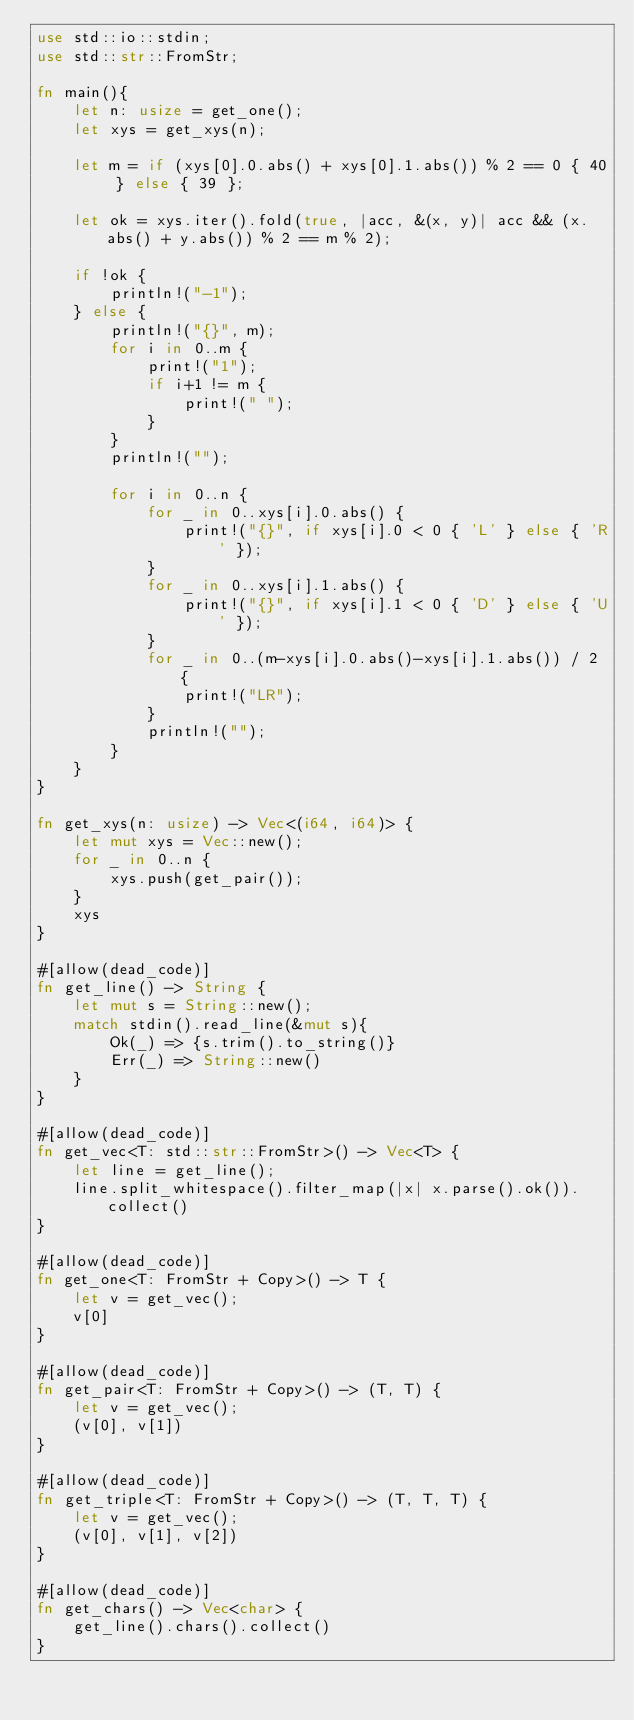<code> <loc_0><loc_0><loc_500><loc_500><_Rust_>use std::io::stdin;
use std::str::FromStr;

fn main(){
    let n: usize = get_one();
    let xys = get_xys(n);

    let m = if (xys[0].0.abs() + xys[0].1.abs()) % 2 == 0 { 40 } else { 39 };

    let ok = xys.iter().fold(true, |acc, &(x, y)| acc && (x.abs() + y.abs()) % 2 == m % 2);

    if !ok {
        println!("-1");
    } else {
        println!("{}", m);
        for i in 0..m {
            print!("1");
            if i+1 != m {
                print!(" ");
            }
        }
        println!("");

        for i in 0..n {
            for _ in 0..xys[i].0.abs() {
                print!("{}", if xys[i].0 < 0 { 'L' } else { 'R' });
            }
            for _ in 0..xys[i].1.abs() {
                print!("{}", if xys[i].1 < 0 { 'D' } else { 'U' });
            }
            for _ in 0..(m-xys[i].0.abs()-xys[i].1.abs()) / 2 {
                print!("LR");
            }
            println!("");
        }
    }
}

fn get_xys(n: usize) -> Vec<(i64, i64)> {
    let mut xys = Vec::new();
    for _ in 0..n {
        xys.push(get_pair());
    }
    xys
}

#[allow(dead_code)]
fn get_line() -> String {
    let mut s = String::new();
    match stdin().read_line(&mut s){
        Ok(_) => {s.trim().to_string()}
        Err(_) => String::new()
    }
}

#[allow(dead_code)]
fn get_vec<T: std::str::FromStr>() -> Vec<T> {
    let line = get_line();
    line.split_whitespace().filter_map(|x| x.parse().ok()).collect()
}

#[allow(dead_code)]
fn get_one<T: FromStr + Copy>() -> T {
    let v = get_vec();
    v[0]
}

#[allow(dead_code)]
fn get_pair<T: FromStr + Copy>() -> (T, T) {
    let v = get_vec();
    (v[0], v[1])
}

#[allow(dead_code)]
fn get_triple<T: FromStr + Copy>() -> (T, T, T) {
    let v = get_vec();
    (v[0], v[1], v[2])
}

#[allow(dead_code)]
fn get_chars() -> Vec<char> {
    get_line().chars().collect()
}
</code> 